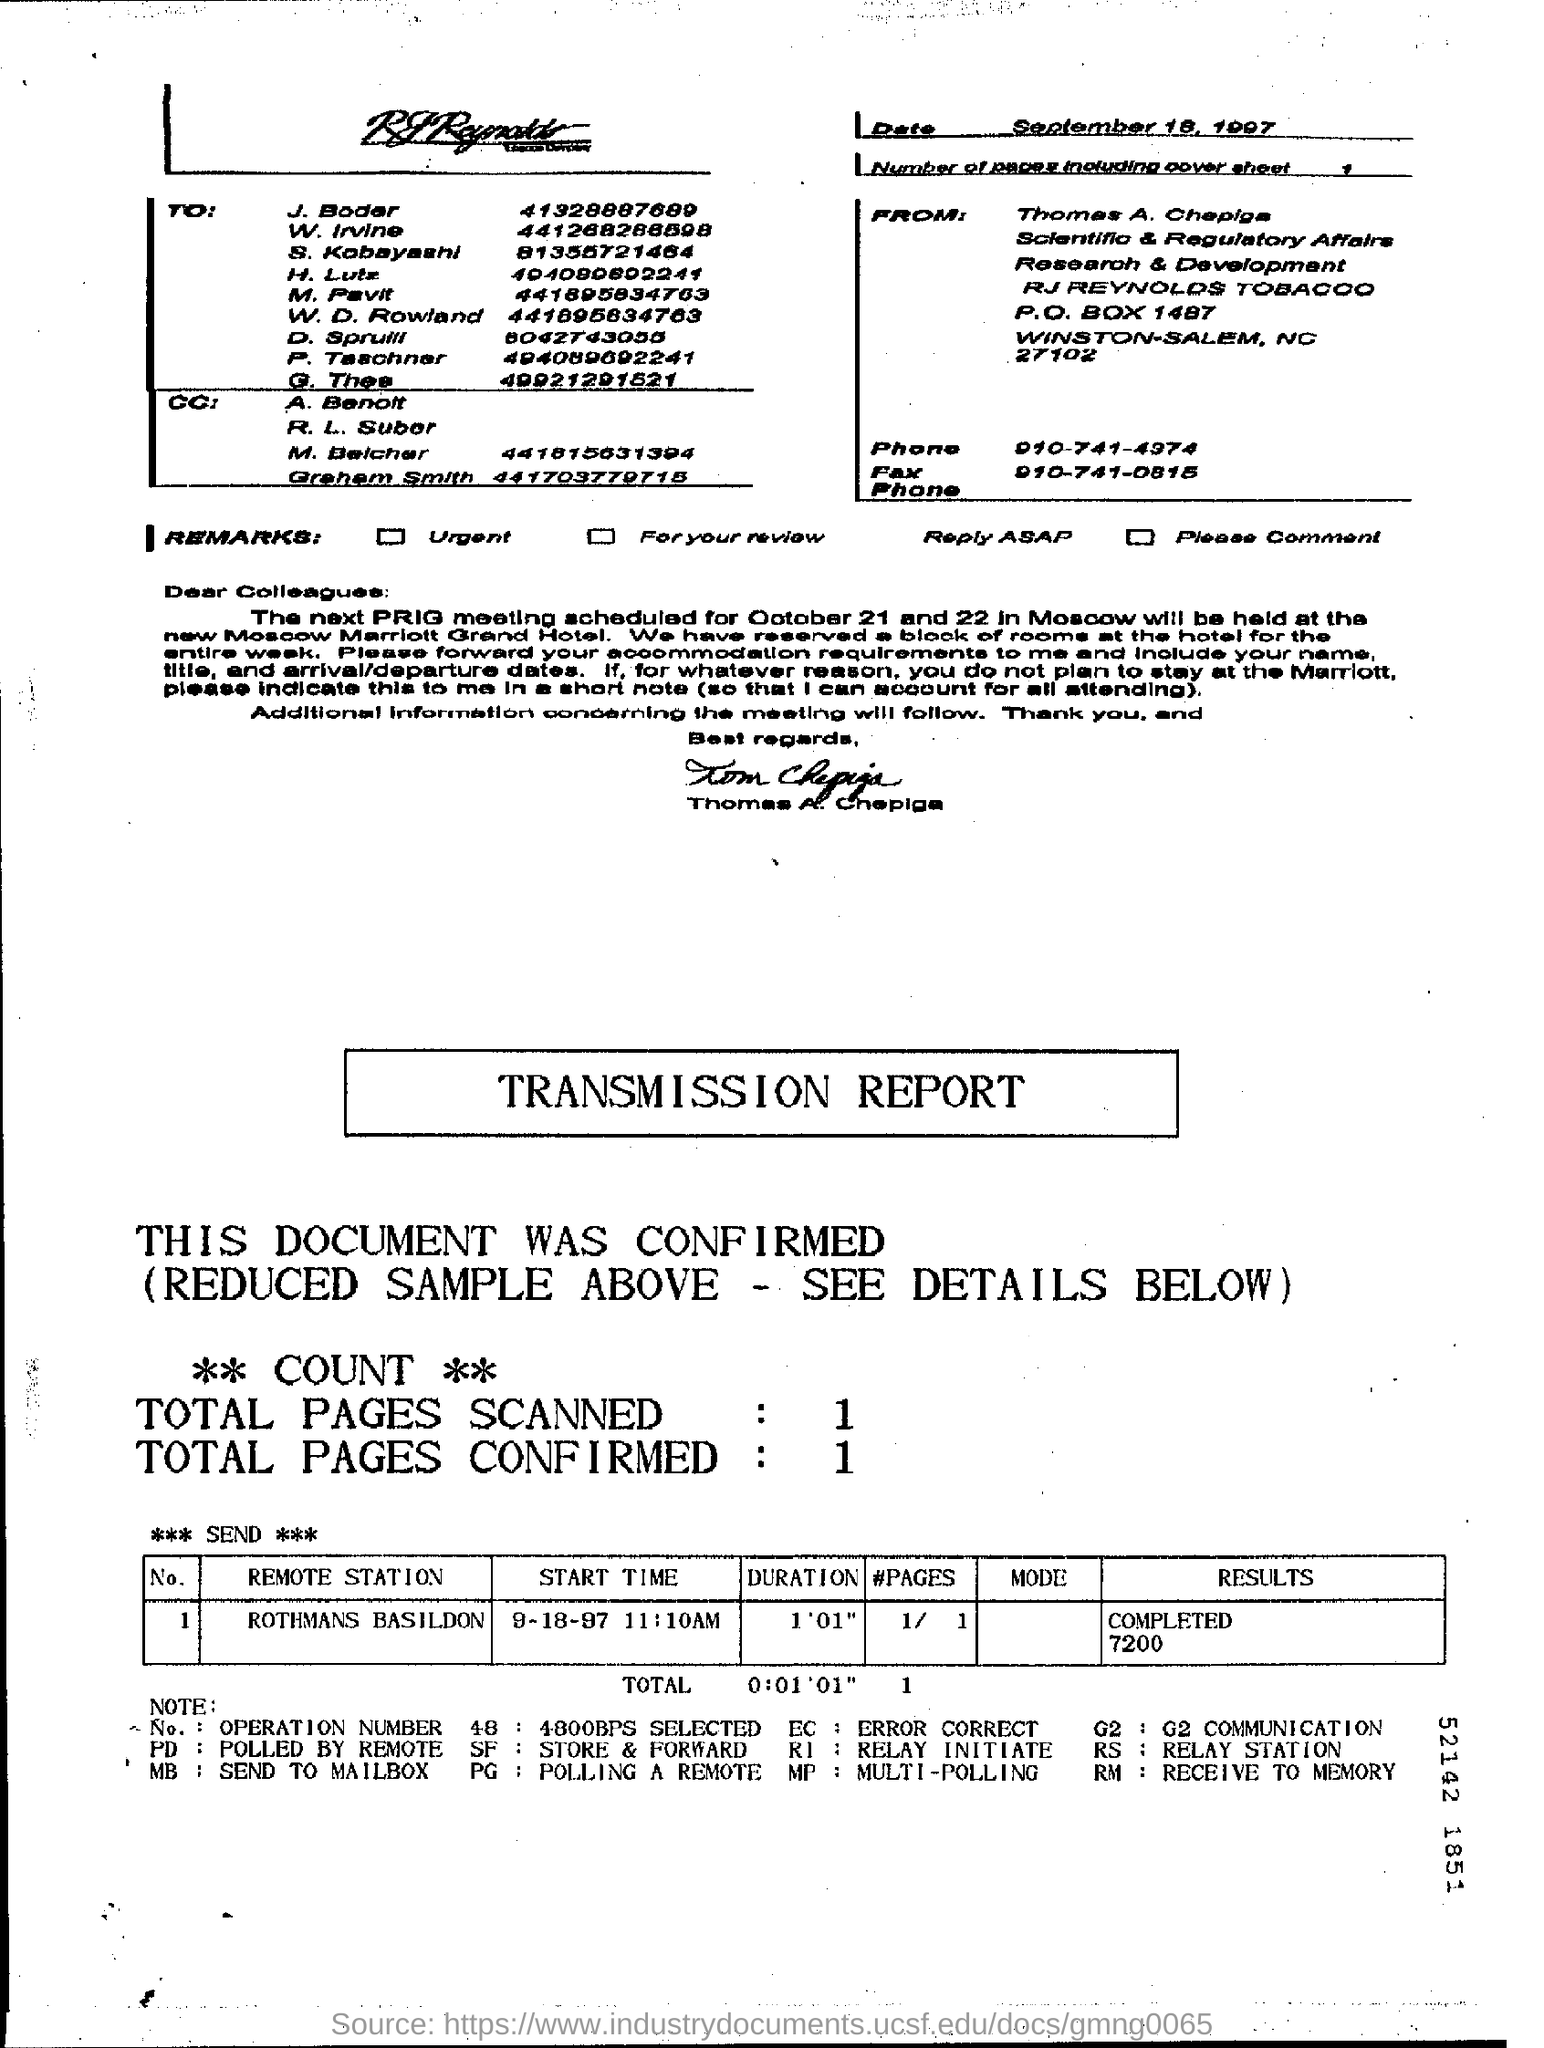Draw attention to some important aspects in this diagram. The letter is from Tom Chepiga. The completion status for the remote station "Rothmans Basildon" is 7200. This status indicates that the remote station has been completed. The total number of pages scanned is 1.. The "START TIME" for the "Remote Station" located at "ROTHMANS BASILDON" on 9-18-97 was 11:10 AM. The total number of pages confirmed is 1.. 